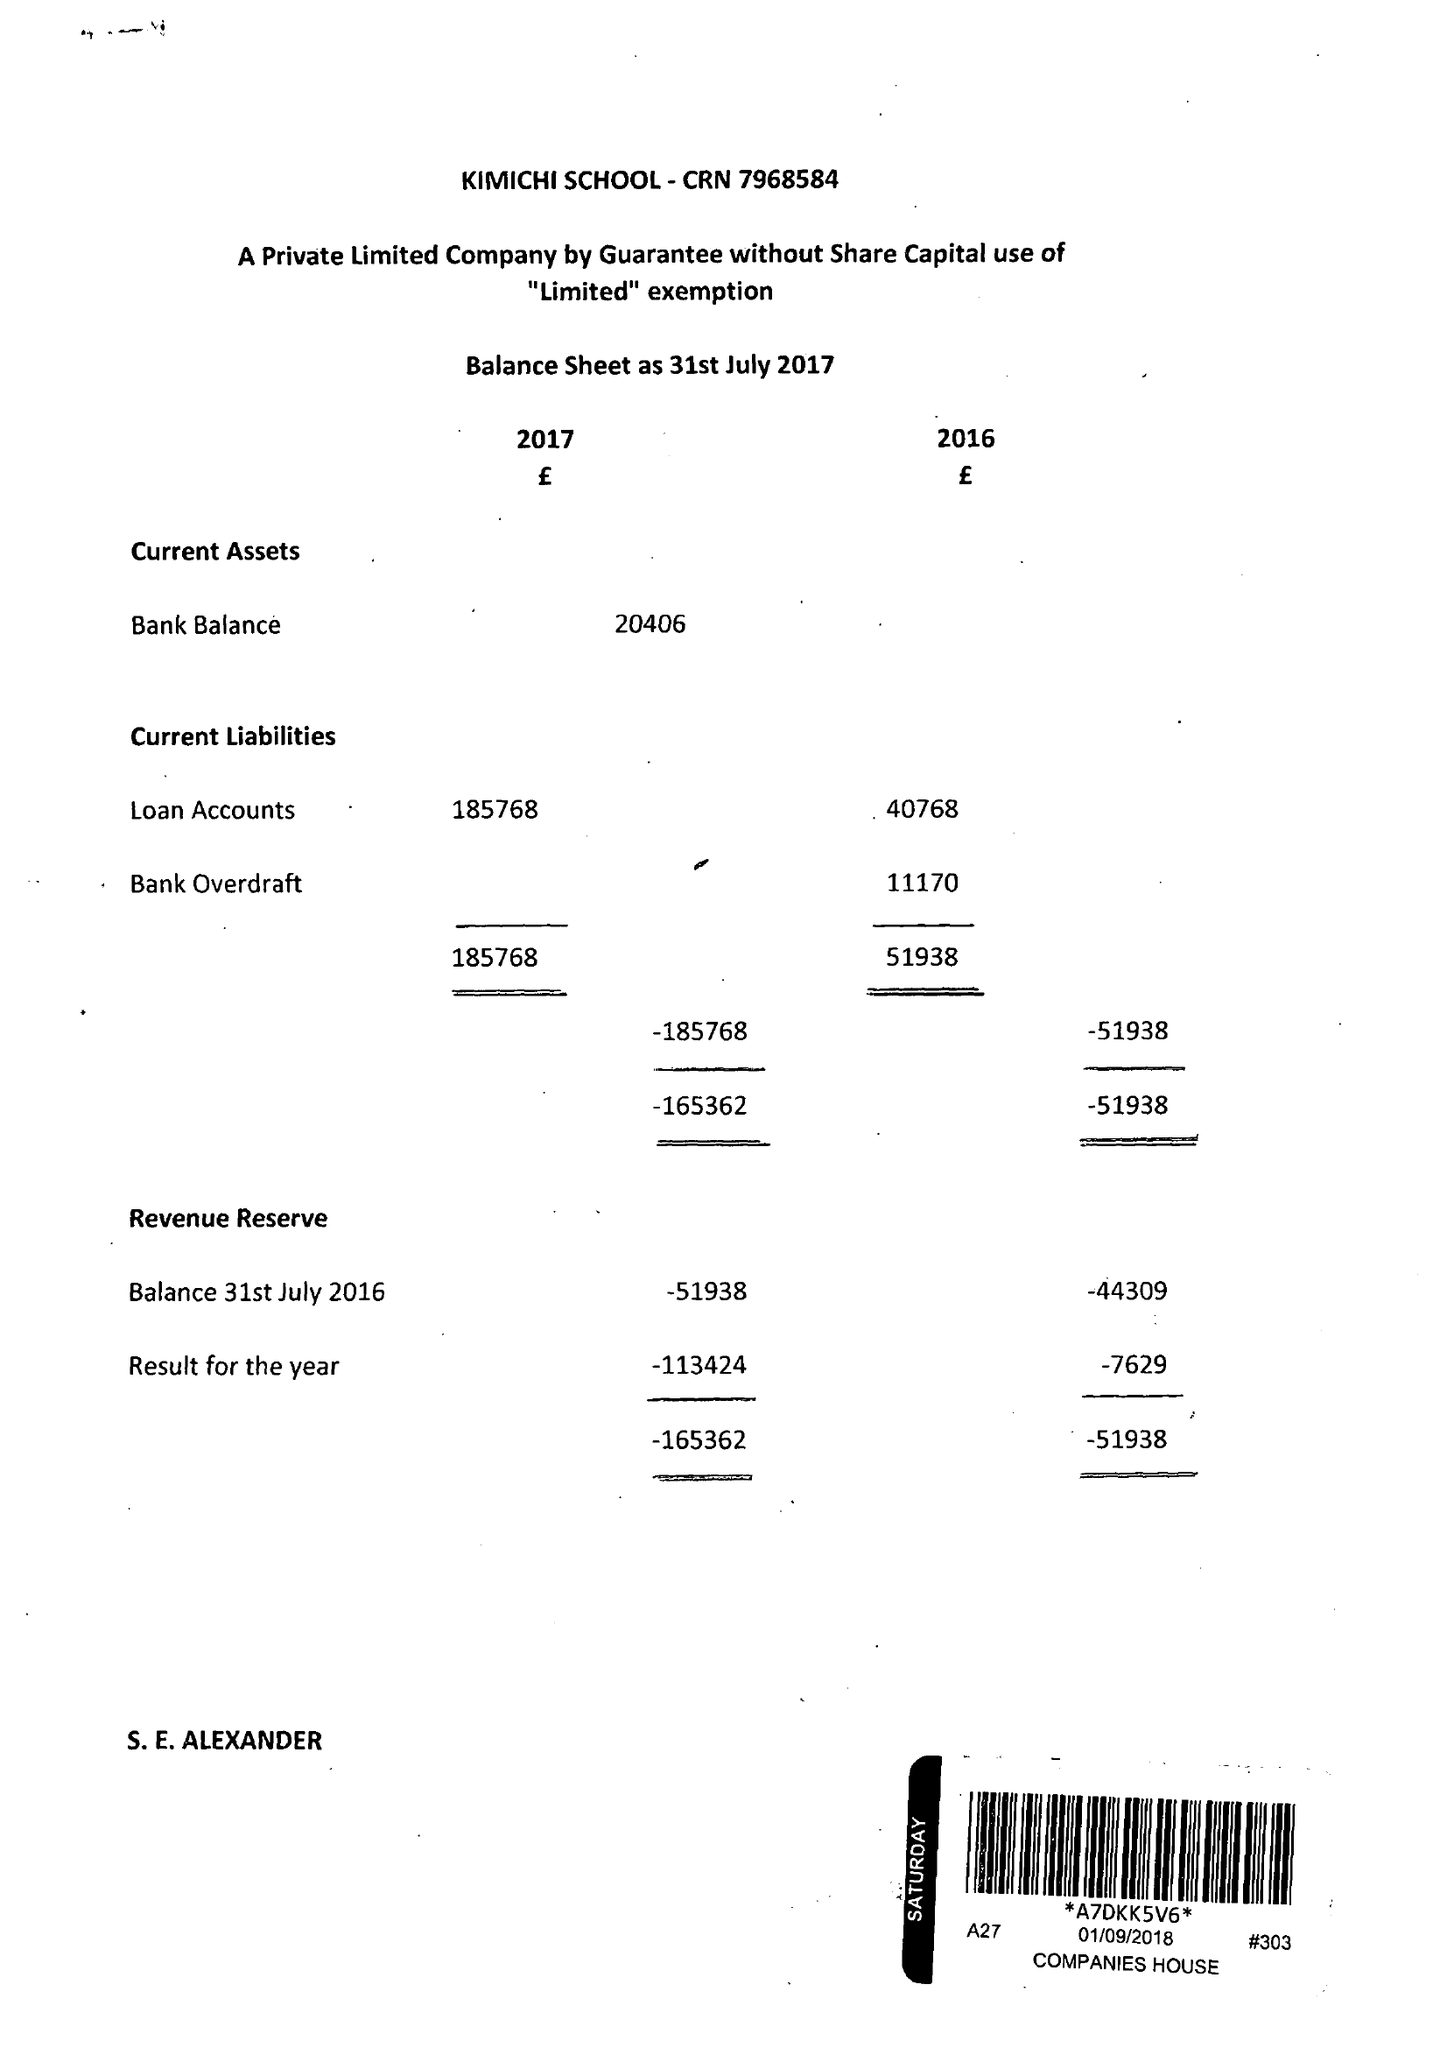What is the value for the address__postcode?
Answer the question using a single word or phrase. B27 6LL 